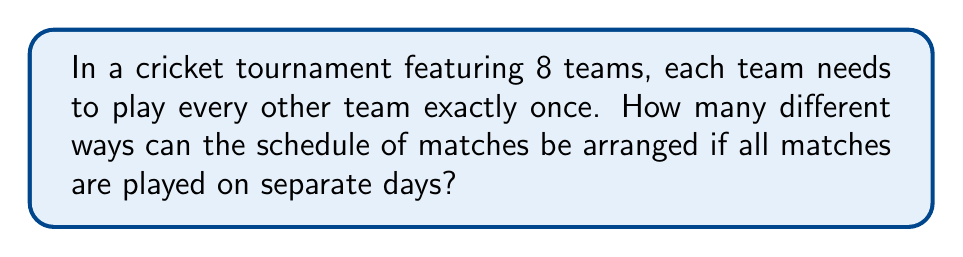Solve this math problem. Let's approach this step-by-step:

1) First, we need to calculate the total number of matches. With 8 teams, each team plays 7 other teams. The total number of matches is:

   $$ \frac{8 \times 7}{2} = 28 $$

2) Now, we need to arrange these 28 matches. This is equivalent to arranging 28 distinct objects, which can be done in 28! ways.

3) However, this count includes permutations that swap the order of teams within a match, which doesn't create a new schedule. For each match, there are 2! = 2 ways to order the teams.

4) Since there are 28 matches, and for each match, we've counted 2 equivalent arrangements, we need to divide our total by $2^{28}$.

5) Therefore, the number of possible schedules is:

   $$ \frac{28!}{2^{28}} $$

6) This can be simplified as:

   $$ \frac{28!}{268,435,456} $$
Answer: $\frac{28!}{2^{28}}$ 